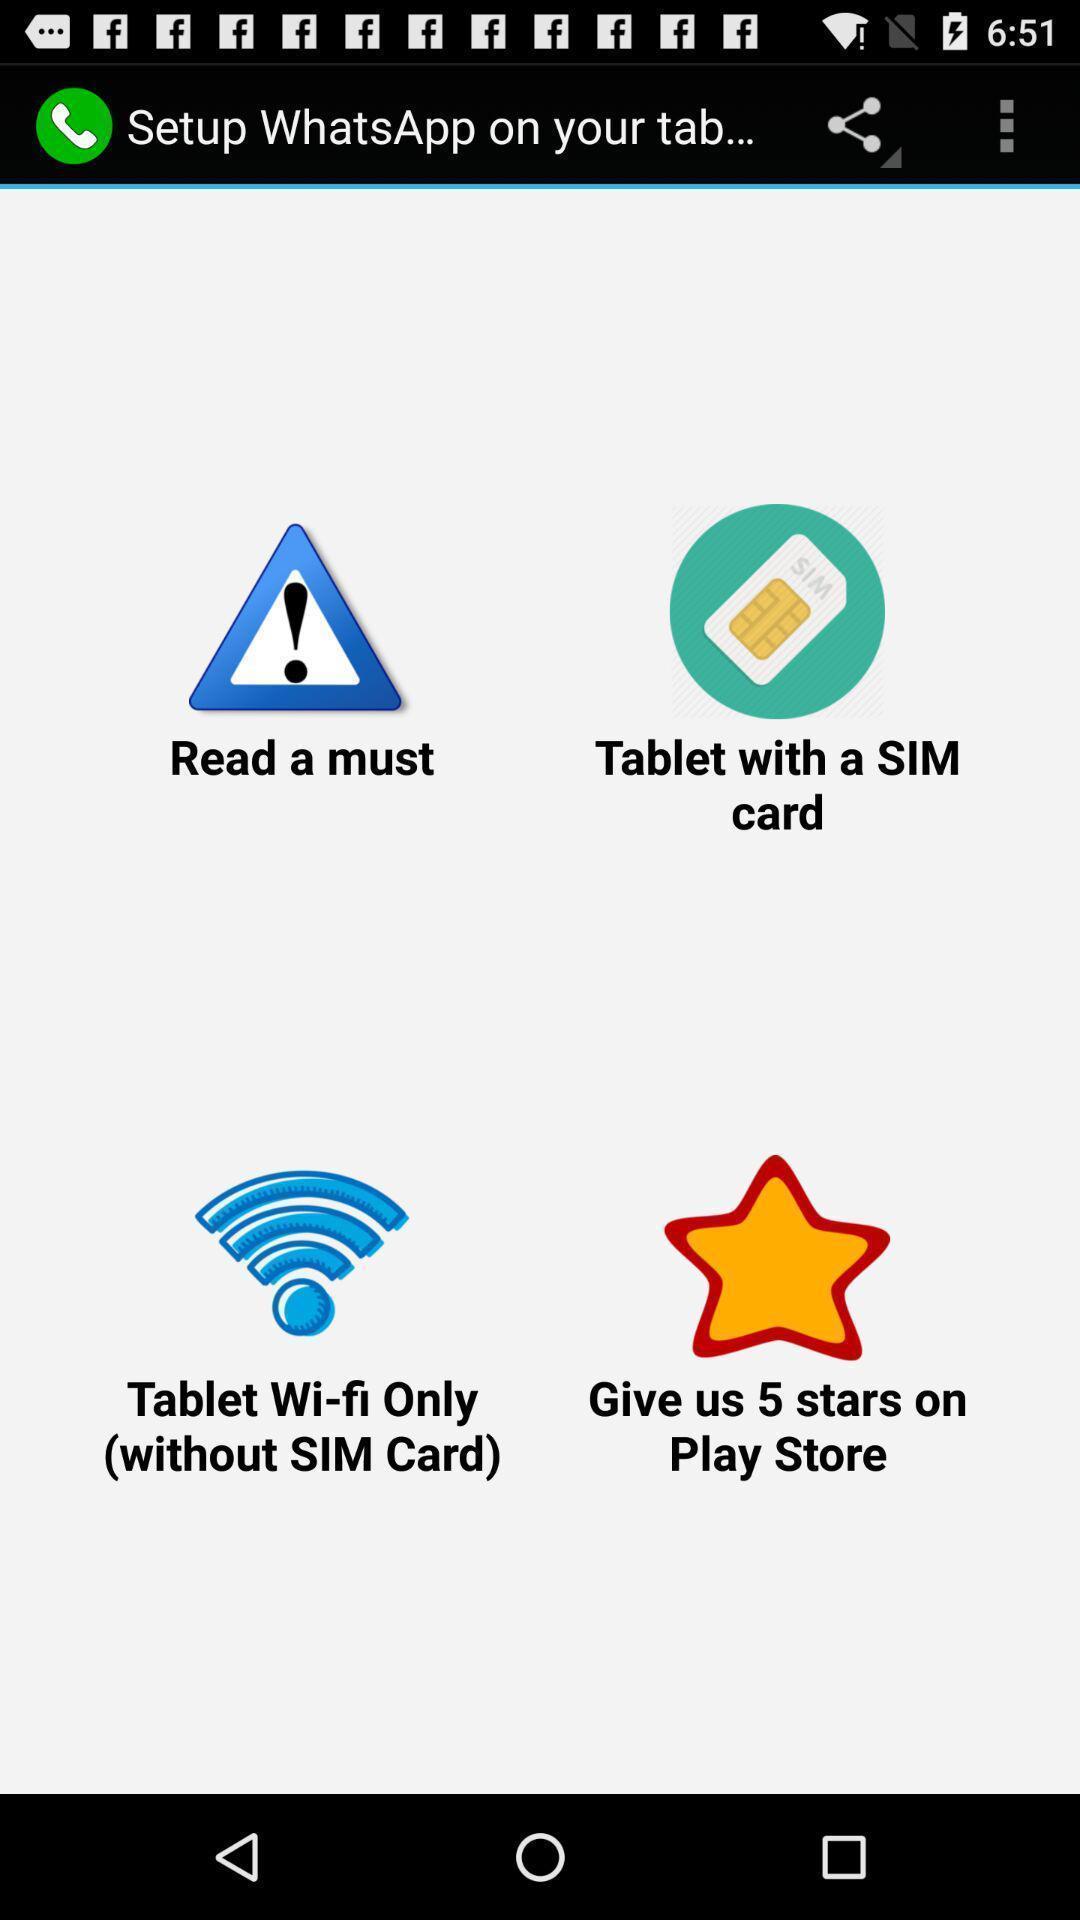Describe this image in words. Screen displaying setup options on a browser. 